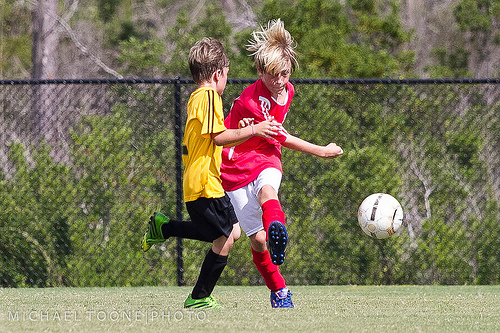<image>
Is there a ball behind the fence? No. The ball is not behind the fence. From this viewpoint, the ball appears to be positioned elsewhere in the scene. 